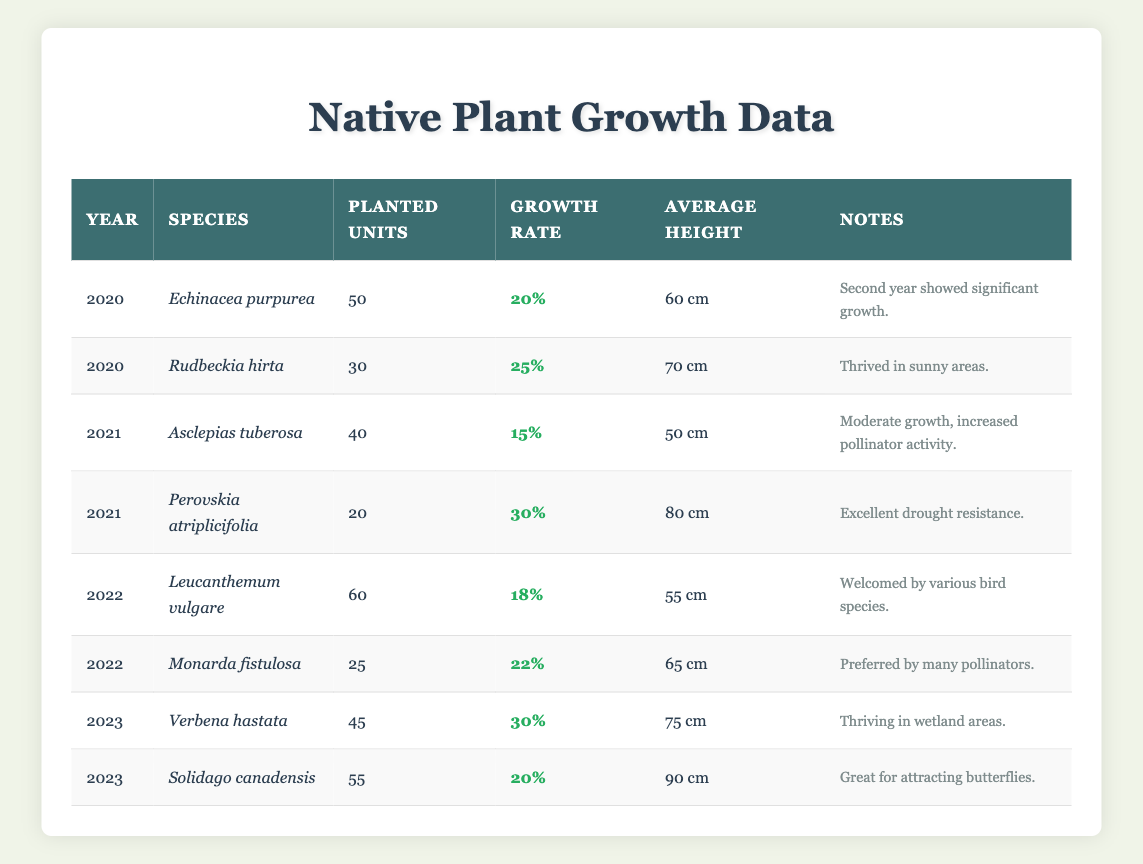What was the highest growth rate recorded for a species in 2023? The species with the highest growth rate in 2023 is Verbena hastata, which had a growth rate of 30%. This can be found by examining the growth rates for each species listed under the year 2023.
Answer: 30% Which species had the greatest number of planted units in 2022? In 2022, the species with the greatest number of planted units is Leucanthemum vulgare, which had 60 planted units. This is identified by comparing the planted units for all species in the year 2022.
Answer: Leucanthemum vulgare What is the average height of the native plants grown in 2021? The average height for plants grown in 2021 can be calculated by summing the heights of Asclepias tuberosa (50 cm) and Perovskia atriplicifolia (80 cm), making a total of 130 cm. Dividing by the number of species (2), the average height is 130 cm / 2 = 65 cm.
Answer: 65 cm Did any species planted in 2020 have a growth rate of over 20%? Yes, Rudbeckia hirta, which was planted in 2020, had a growth rate of 25%, which is over 20%. This is verified by checking the growth rates for all species listed in 2020.
Answer: Yes What was the total number of planted units for all species in 2023? The total number of planted units for 2023 is calculated by adding all the planted units in that year: Verbena hastata (45) + Solidago canadensis (55) = 100 planted units.
Answer: 100 